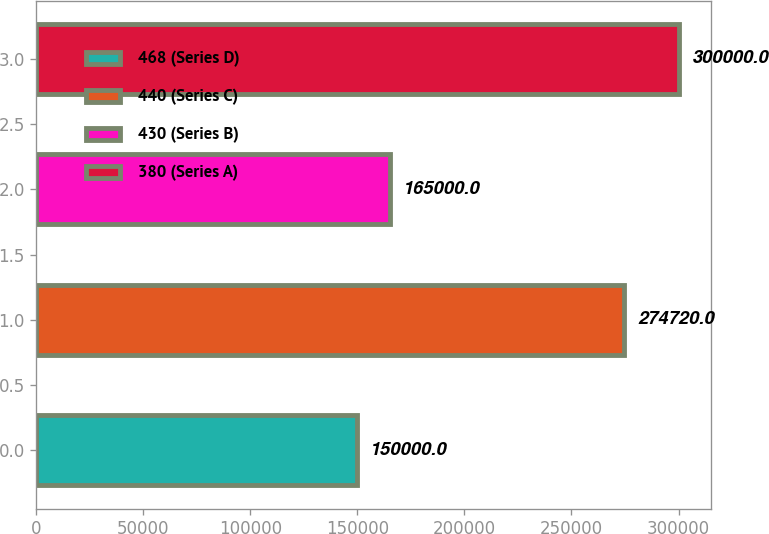<chart> <loc_0><loc_0><loc_500><loc_500><bar_chart><fcel>468 (Series D)<fcel>440 (Series C)<fcel>430 (Series B)<fcel>380 (Series A)<nl><fcel>150000<fcel>274720<fcel>165000<fcel>300000<nl></chart> 